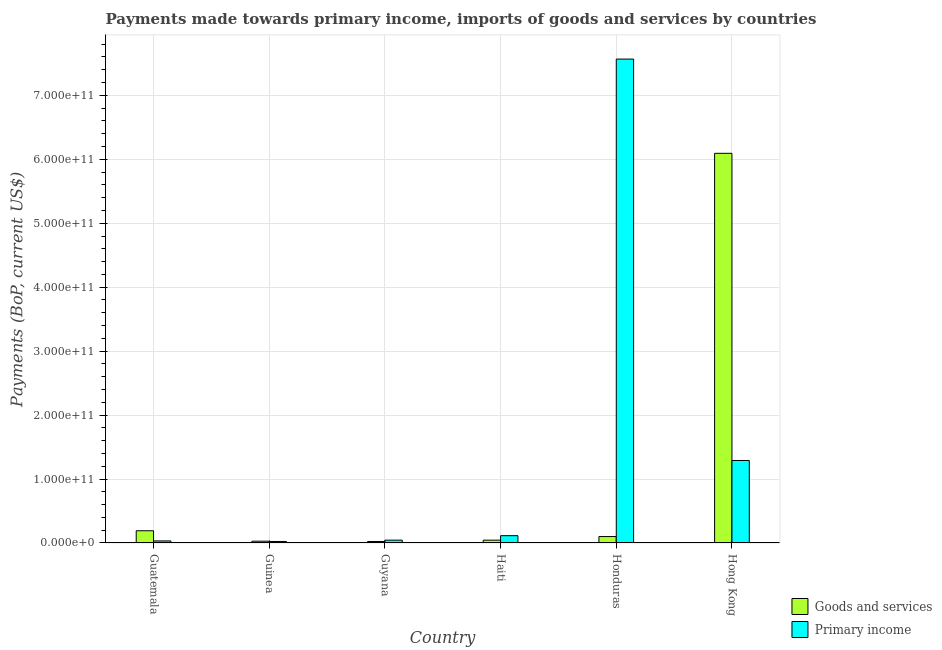How many different coloured bars are there?
Offer a terse response. 2. How many groups of bars are there?
Keep it short and to the point. 6. Are the number of bars on each tick of the X-axis equal?
Offer a very short reply. Yes. How many bars are there on the 1st tick from the left?
Your answer should be compact. 2. What is the label of the 5th group of bars from the left?
Your response must be concise. Honduras. In how many cases, is the number of bars for a given country not equal to the number of legend labels?
Ensure brevity in your answer.  0. What is the payments made towards primary income in Honduras?
Keep it short and to the point. 7.57e+11. Across all countries, what is the maximum payments made towards goods and services?
Offer a terse response. 6.09e+11. Across all countries, what is the minimum payments made towards goods and services?
Offer a very short reply. 2.35e+09. In which country was the payments made towards primary income maximum?
Provide a short and direct response. Honduras. In which country was the payments made towards primary income minimum?
Ensure brevity in your answer.  Guinea. What is the total payments made towards primary income in the graph?
Provide a succinct answer. 9.07e+11. What is the difference between the payments made towards primary income in Haiti and that in Hong Kong?
Give a very brief answer. -1.18e+11. What is the difference between the payments made towards goods and services in Guyana and the payments made towards primary income in Hong Kong?
Your response must be concise. -1.27e+11. What is the average payments made towards goods and services per country?
Offer a very short reply. 1.08e+11. What is the difference between the payments made towards goods and services and payments made towards primary income in Guyana?
Ensure brevity in your answer.  -2.09e+09. In how many countries, is the payments made towards goods and services greater than 200000000000 US$?
Make the answer very short. 1. What is the ratio of the payments made towards primary income in Guatemala to that in Honduras?
Provide a succinct answer. 0. Is the payments made towards goods and services in Guyana less than that in Haiti?
Offer a very short reply. Yes. What is the difference between the highest and the second highest payments made towards primary income?
Your answer should be compact. 6.28e+11. What is the difference between the highest and the lowest payments made towards goods and services?
Make the answer very short. 6.07e+11. What does the 2nd bar from the left in Hong Kong represents?
Make the answer very short. Primary income. What does the 1st bar from the right in Haiti represents?
Provide a succinct answer. Primary income. How many bars are there?
Offer a terse response. 12. Are all the bars in the graph horizontal?
Offer a terse response. No. How many countries are there in the graph?
Offer a terse response. 6. What is the difference between two consecutive major ticks on the Y-axis?
Keep it short and to the point. 1.00e+11. Are the values on the major ticks of Y-axis written in scientific E-notation?
Offer a very short reply. Yes. Does the graph contain grids?
Your response must be concise. Yes. Where does the legend appear in the graph?
Ensure brevity in your answer.  Bottom right. What is the title of the graph?
Offer a very short reply. Payments made towards primary income, imports of goods and services by countries. Does "Drinking water services" appear as one of the legend labels in the graph?
Ensure brevity in your answer.  No. What is the label or title of the X-axis?
Provide a succinct answer. Country. What is the label or title of the Y-axis?
Ensure brevity in your answer.  Payments (BoP, current US$). What is the Payments (BoP, current US$) of Goods and services in Guatemala?
Offer a terse response. 1.91e+1. What is the Payments (BoP, current US$) of Primary income in Guatemala?
Keep it short and to the point. 3.24e+09. What is the Payments (BoP, current US$) of Goods and services in Guinea?
Provide a short and direct response. 2.83e+09. What is the Payments (BoP, current US$) of Primary income in Guinea?
Give a very brief answer. 2.36e+09. What is the Payments (BoP, current US$) in Goods and services in Guyana?
Keep it short and to the point. 2.35e+09. What is the Payments (BoP, current US$) of Primary income in Guyana?
Offer a terse response. 4.43e+09. What is the Payments (BoP, current US$) of Goods and services in Haiti?
Offer a very short reply. 4.42e+09. What is the Payments (BoP, current US$) of Primary income in Haiti?
Provide a short and direct response. 1.14e+1. What is the Payments (BoP, current US$) of Goods and services in Honduras?
Give a very brief answer. 1.01e+1. What is the Payments (BoP, current US$) in Primary income in Honduras?
Offer a terse response. 7.57e+11. What is the Payments (BoP, current US$) of Goods and services in Hong Kong?
Give a very brief answer. 6.09e+11. What is the Payments (BoP, current US$) in Primary income in Hong Kong?
Provide a short and direct response. 1.29e+11. Across all countries, what is the maximum Payments (BoP, current US$) of Goods and services?
Offer a very short reply. 6.09e+11. Across all countries, what is the maximum Payments (BoP, current US$) in Primary income?
Ensure brevity in your answer.  7.57e+11. Across all countries, what is the minimum Payments (BoP, current US$) of Goods and services?
Offer a terse response. 2.35e+09. Across all countries, what is the minimum Payments (BoP, current US$) in Primary income?
Provide a succinct answer. 2.36e+09. What is the total Payments (BoP, current US$) in Goods and services in the graph?
Ensure brevity in your answer.  6.48e+11. What is the total Payments (BoP, current US$) of Primary income in the graph?
Provide a short and direct response. 9.07e+11. What is the difference between the Payments (BoP, current US$) of Goods and services in Guatemala and that in Guinea?
Your answer should be very brief. 1.63e+1. What is the difference between the Payments (BoP, current US$) of Primary income in Guatemala and that in Guinea?
Offer a very short reply. 8.79e+08. What is the difference between the Payments (BoP, current US$) in Goods and services in Guatemala and that in Guyana?
Make the answer very short. 1.68e+1. What is the difference between the Payments (BoP, current US$) of Primary income in Guatemala and that in Guyana?
Your answer should be very brief. -1.19e+09. What is the difference between the Payments (BoP, current US$) in Goods and services in Guatemala and that in Haiti?
Your response must be concise. 1.47e+1. What is the difference between the Payments (BoP, current US$) in Primary income in Guatemala and that in Haiti?
Your response must be concise. -8.19e+09. What is the difference between the Payments (BoP, current US$) in Goods and services in Guatemala and that in Honduras?
Make the answer very short. 9.04e+09. What is the difference between the Payments (BoP, current US$) in Primary income in Guatemala and that in Honduras?
Provide a succinct answer. -7.53e+11. What is the difference between the Payments (BoP, current US$) of Goods and services in Guatemala and that in Hong Kong?
Your answer should be very brief. -5.90e+11. What is the difference between the Payments (BoP, current US$) in Primary income in Guatemala and that in Hong Kong?
Provide a short and direct response. -1.26e+11. What is the difference between the Payments (BoP, current US$) of Goods and services in Guinea and that in Guyana?
Ensure brevity in your answer.  4.86e+08. What is the difference between the Payments (BoP, current US$) in Primary income in Guinea and that in Guyana?
Offer a terse response. -2.07e+09. What is the difference between the Payments (BoP, current US$) of Goods and services in Guinea and that in Haiti?
Keep it short and to the point. -1.59e+09. What is the difference between the Payments (BoP, current US$) in Primary income in Guinea and that in Haiti?
Provide a succinct answer. -9.07e+09. What is the difference between the Payments (BoP, current US$) of Goods and services in Guinea and that in Honduras?
Your answer should be very brief. -7.24e+09. What is the difference between the Payments (BoP, current US$) of Primary income in Guinea and that in Honduras?
Offer a very short reply. -7.54e+11. What is the difference between the Payments (BoP, current US$) in Goods and services in Guinea and that in Hong Kong?
Keep it short and to the point. -6.06e+11. What is the difference between the Payments (BoP, current US$) in Primary income in Guinea and that in Hong Kong?
Provide a succinct answer. -1.27e+11. What is the difference between the Payments (BoP, current US$) of Goods and services in Guyana and that in Haiti?
Provide a short and direct response. -2.07e+09. What is the difference between the Payments (BoP, current US$) of Primary income in Guyana and that in Haiti?
Offer a very short reply. -7.00e+09. What is the difference between the Payments (BoP, current US$) in Goods and services in Guyana and that in Honduras?
Provide a short and direct response. -7.72e+09. What is the difference between the Payments (BoP, current US$) in Primary income in Guyana and that in Honduras?
Give a very brief answer. -7.52e+11. What is the difference between the Payments (BoP, current US$) of Goods and services in Guyana and that in Hong Kong?
Keep it short and to the point. -6.07e+11. What is the difference between the Payments (BoP, current US$) of Primary income in Guyana and that in Hong Kong?
Offer a terse response. -1.25e+11. What is the difference between the Payments (BoP, current US$) of Goods and services in Haiti and that in Honduras?
Keep it short and to the point. -5.65e+09. What is the difference between the Payments (BoP, current US$) in Primary income in Haiti and that in Honduras?
Ensure brevity in your answer.  -7.45e+11. What is the difference between the Payments (BoP, current US$) of Goods and services in Haiti and that in Hong Kong?
Give a very brief answer. -6.05e+11. What is the difference between the Payments (BoP, current US$) in Primary income in Haiti and that in Hong Kong?
Keep it short and to the point. -1.18e+11. What is the difference between the Payments (BoP, current US$) of Goods and services in Honduras and that in Hong Kong?
Make the answer very short. -5.99e+11. What is the difference between the Payments (BoP, current US$) of Primary income in Honduras and that in Hong Kong?
Keep it short and to the point. 6.28e+11. What is the difference between the Payments (BoP, current US$) in Goods and services in Guatemala and the Payments (BoP, current US$) in Primary income in Guinea?
Your response must be concise. 1.68e+1. What is the difference between the Payments (BoP, current US$) in Goods and services in Guatemala and the Payments (BoP, current US$) in Primary income in Guyana?
Keep it short and to the point. 1.47e+1. What is the difference between the Payments (BoP, current US$) of Goods and services in Guatemala and the Payments (BoP, current US$) of Primary income in Haiti?
Provide a succinct answer. 7.68e+09. What is the difference between the Payments (BoP, current US$) of Goods and services in Guatemala and the Payments (BoP, current US$) of Primary income in Honduras?
Provide a succinct answer. -7.38e+11. What is the difference between the Payments (BoP, current US$) of Goods and services in Guatemala and the Payments (BoP, current US$) of Primary income in Hong Kong?
Offer a terse response. -1.10e+11. What is the difference between the Payments (BoP, current US$) of Goods and services in Guinea and the Payments (BoP, current US$) of Primary income in Guyana?
Make the answer very short. -1.60e+09. What is the difference between the Payments (BoP, current US$) of Goods and services in Guinea and the Payments (BoP, current US$) of Primary income in Haiti?
Make the answer very short. -8.60e+09. What is the difference between the Payments (BoP, current US$) of Goods and services in Guinea and the Payments (BoP, current US$) of Primary income in Honduras?
Offer a terse response. -7.54e+11. What is the difference between the Payments (BoP, current US$) of Goods and services in Guinea and the Payments (BoP, current US$) of Primary income in Hong Kong?
Your answer should be compact. -1.26e+11. What is the difference between the Payments (BoP, current US$) of Goods and services in Guyana and the Payments (BoP, current US$) of Primary income in Haiti?
Make the answer very short. -9.08e+09. What is the difference between the Payments (BoP, current US$) of Goods and services in Guyana and the Payments (BoP, current US$) of Primary income in Honduras?
Ensure brevity in your answer.  -7.54e+11. What is the difference between the Payments (BoP, current US$) of Goods and services in Guyana and the Payments (BoP, current US$) of Primary income in Hong Kong?
Ensure brevity in your answer.  -1.27e+11. What is the difference between the Payments (BoP, current US$) in Goods and services in Haiti and the Payments (BoP, current US$) in Primary income in Honduras?
Your response must be concise. -7.52e+11. What is the difference between the Payments (BoP, current US$) in Goods and services in Haiti and the Payments (BoP, current US$) in Primary income in Hong Kong?
Your answer should be compact. -1.25e+11. What is the difference between the Payments (BoP, current US$) in Goods and services in Honduras and the Payments (BoP, current US$) in Primary income in Hong Kong?
Offer a terse response. -1.19e+11. What is the average Payments (BoP, current US$) of Goods and services per country?
Your answer should be very brief. 1.08e+11. What is the average Payments (BoP, current US$) of Primary income per country?
Make the answer very short. 1.51e+11. What is the difference between the Payments (BoP, current US$) of Goods and services and Payments (BoP, current US$) of Primary income in Guatemala?
Give a very brief answer. 1.59e+1. What is the difference between the Payments (BoP, current US$) of Goods and services and Payments (BoP, current US$) of Primary income in Guinea?
Give a very brief answer. 4.70e+08. What is the difference between the Payments (BoP, current US$) in Goods and services and Payments (BoP, current US$) in Primary income in Guyana?
Provide a short and direct response. -2.09e+09. What is the difference between the Payments (BoP, current US$) of Goods and services and Payments (BoP, current US$) of Primary income in Haiti?
Offer a terse response. -7.01e+09. What is the difference between the Payments (BoP, current US$) of Goods and services and Payments (BoP, current US$) of Primary income in Honduras?
Give a very brief answer. -7.47e+11. What is the difference between the Payments (BoP, current US$) in Goods and services and Payments (BoP, current US$) in Primary income in Hong Kong?
Give a very brief answer. 4.80e+11. What is the ratio of the Payments (BoP, current US$) of Goods and services in Guatemala to that in Guinea?
Offer a very short reply. 6.75. What is the ratio of the Payments (BoP, current US$) of Primary income in Guatemala to that in Guinea?
Your answer should be compact. 1.37. What is the ratio of the Payments (BoP, current US$) in Goods and services in Guatemala to that in Guyana?
Ensure brevity in your answer.  8.14. What is the ratio of the Payments (BoP, current US$) of Primary income in Guatemala to that in Guyana?
Give a very brief answer. 0.73. What is the ratio of the Payments (BoP, current US$) of Goods and services in Guatemala to that in Haiti?
Provide a succinct answer. 4.33. What is the ratio of the Payments (BoP, current US$) of Primary income in Guatemala to that in Haiti?
Your answer should be very brief. 0.28. What is the ratio of the Payments (BoP, current US$) of Goods and services in Guatemala to that in Honduras?
Offer a terse response. 1.9. What is the ratio of the Payments (BoP, current US$) of Primary income in Guatemala to that in Honduras?
Ensure brevity in your answer.  0. What is the ratio of the Payments (BoP, current US$) of Goods and services in Guatemala to that in Hong Kong?
Offer a very short reply. 0.03. What is the ratio of the Payments (BoP, current US$) in Primary income in Guatemala to that in Hong Kong?
Provide a short and direct response. 0.03. What is the ratio of the Payments (BoP, current US$) in Goods and services in Guinea to that in Guyana?
Your answer should be very brief. 1.21. What is the ratio of the Payments (BoP, current US$) in Primary income in Guinea to that in Guyana?
Your answer should be very brief. 0.53. What is the ratio of the Payments (BoP, current US$) of Goods and services in Guinea to that in Haiti?
Keep it short and to the point. 0.64. What is the ratio of the Payments (BoP, current US$) in Primary income in Guinea to that in Haiti?
Make the answer very short. 0.21. What is the ratio of the Payments (BoP, current US$) in Goods and services in Guinea to that in Honduras?
Provide a succinct answer. 0.28. What is the ratio of the Payments (BoP, current US$) in Primary income in Guinea to that in Honduras?
Your answer should be very brief. 0. What is the ratio of the Payments (BoP, current US$) of Goods and services in Guinea to that in Hong Kong?
Give a very brief answer. 0. What is the ratio of the Payments (BoP, current US$) of Primary income in Guinea to that in Hong Kong?
Provide a succinct answer. 0.02. What is the ratio of the Payments (BoP, current US$) of Goods and services in Guyana to that in Haiti?
Your answer should be very brief. 0.53. What is the ratio of the Payments (BoP, current US$) in Primary income in Guyana to that in Haiti?
Provide a succinct answer. 0.39. What is the ratio of the Payments (BoP, current US$) in Goods and services in Guyana to that in Honduras?
Your response must be concise. 0.23. What is the ratio of the Payments (BoP, current US$) in Primary income in Guyana to that in Honduras?
Provide a succinct answer. 0.01. What is the ratio of the Payments (BoP, current US$) of Goods and services in Guyana to that in Hong Kong?
Offer a very short reply. 0. What is the ratio of the Payments (BoP, current US$) in Primary income in Guyana to that in Hong Kong?
Make the answer very short. 0.03. What is the ratio of the Payments (BoP, current US$) in Goods and services in Haiti to that in Honduras?
Make the answer very short. 0.44. What is the ratio of the Payments (BoP, current US$) in Primary income in Haiti to that in Honduras?
Offer a terse response. 0.02. What is the ratio of the Payments (BoP, current US$) in Goods and services in Haiti to that in Hong Kong?
Your answer should be compact. 0.01. What is the ratio of the Payments (BoP, current US$) in Primary income in Haiti to that in Hong Kong?
Your answer should be very brief. 0.09. What is the ratio of the Payments (BoP, current US$) in Goods and services in Honduras to that in Hong Kong?
Make the answer very short. 0.02. What is the ratio of the Payments (BoP, current US$) of Primary income in Honduras to that in Hong Kong?
Give a very brief answer. 5.86. What is the difference between the highest and the second highest Payments (BoP, current US$) in Goods and services?
Your response must be concise. 5.90e+11. What is the difference between the highest and the second highest Payments (BoP, current US$) of Primary income?
Provide a short and direct response. 6.28e+11. What is the difference between the highest and the lowest Payments (BoP, current US$) in Goods and services?
Ensure brevity in your answer.  6.07e+11. What is the difference between the highest and the lowest Payments (BoP, current US$) in Primary income?
Keep it short and to the point. 7.54e+11. 